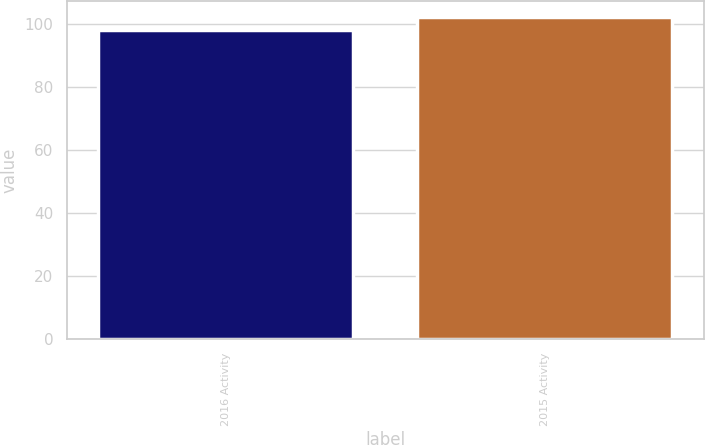<chart> <loc_0><loc_0><loc_500><loc_500><bar_chart><fcel>2016 Activity<fcel>2015 Activity<nl><fcel>98<fcel>102<nl></chart> 